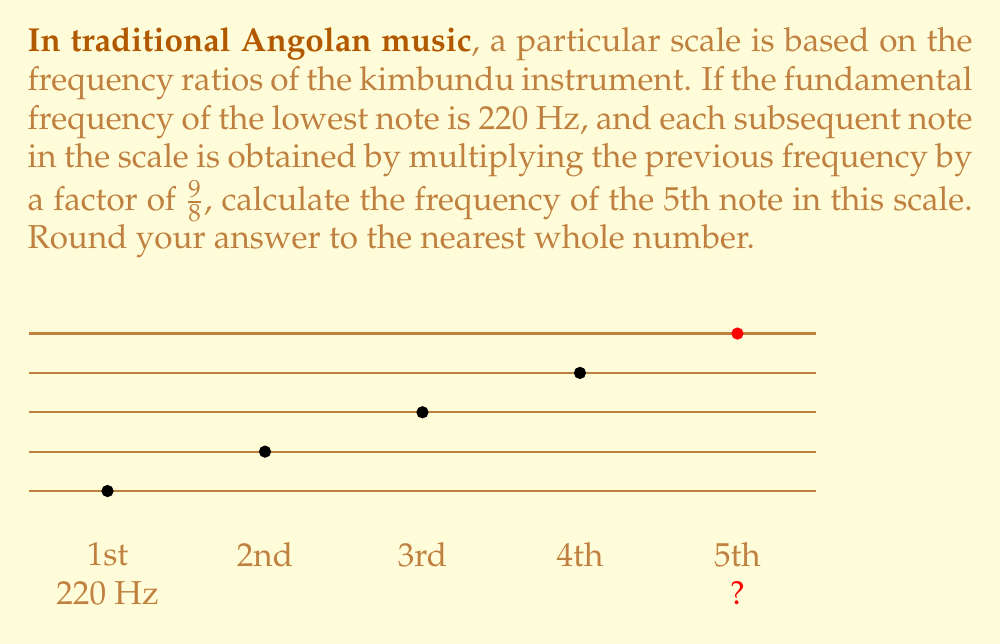Show me your answer to this math problem. Let's approach this step-by-step:

1) We start with the fundamental frequency of 220 Hz.

2) Each note is obtained by multiplying the previous frequency by $\frac{9}{8}$.

3) To get the 5th note, we need to apply this multiplication four times:

   $$f_5 = 220 \cdot (\frac{9}{8})^4$$

4) Let's calculate this:
   
   $$f_5 = 220 \cdot (\frac{9}{8})^4$$
   $$= 220 \cdot \frac{9^4}{8^4}$$
   $$= 220 \cdot \frac{6561}{4096}$$
   $$= 220 \cdot 1.601806640625$$
   $$= 352.3974609375$$

5) Rounding to the nearest whole number:

   $$f_5 \approx 352 \text{ Hz}$$
Answer: 352 Hz 